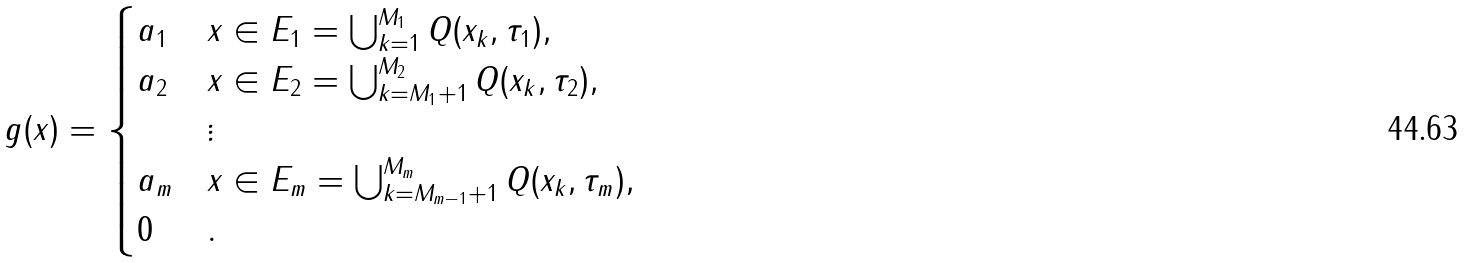Convert formula to latex. <formula><loc_0><loc_0><loc_500><loc_500>g ( x ) = \begin{cases} a _ { 1 } & x \in E _ { 1 } = \bigcup _ { k = 1 } ^ { M _ { 1 } } Q ( x _ { k } , \tau _ { 1 } ) , \\ a _ { 2 } & x \in E _ { 2 } = \bigcup _ { k = M _ { 1 } + 1 } ^ { M _ { 2 } } Q ( x _ { k } , \tau _ { 2 } ) , \\ & \vdots \\ a _ { m } & x \in E _ { m } = \bigcup _ { k = M _ { m - 1 } + 1 } ^ { M _ { m } } Q ( x _ { k } , \tau _ { m } ) , \\ 0 & . \end{cases}</formula> 